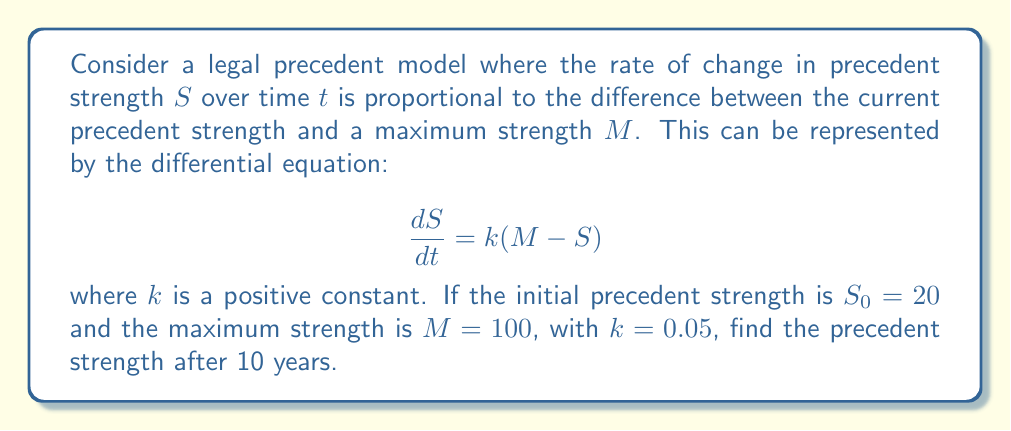Show me your answer to this math problem. 1) We start with the given differential equation:

   $$\frac{dS}{dt} = k(M - S)$$

2) This is a first-order linear differential equation. Its solution is:

   $$S(t) = M + (S_0 - M)e^{-kt}$$

3) We're given the following values:
   $S_0 = 20$ (initial strength)
   $M = 100$ (maximum strength)
   $k = 0.05$ (rate constant)
   $t = 10$ (time in years)

4) Substituting these values into our solution:

   $$S(10) = 100 + (20 - 100)e^{-0.05(10)}$$

5) Simplify:

   $$S(10) = 100 - 80e^{-0.5}$$

6) Calculate $e^{-0.5} \approx 0.6065$:

   $$S(10) = 100 - 80(0.6065) \approx 51.48$$

Therefore, after 10 years, the precedent strength will be approximately 51.48.
Answer: $S(10) \approx 51.48$ 